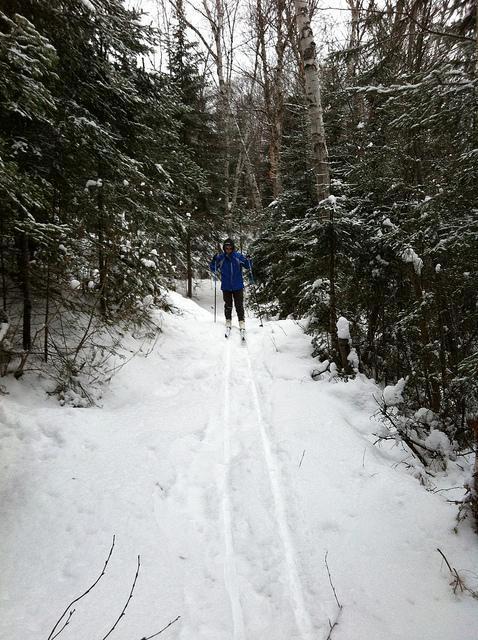How many tracks can be seen in the snow?
Give a very brief answer. 2. How many poles can be seen?
Give a very brief answer. 2. How many news anchors are on the television screen?
Give a very brief answer. 0. 